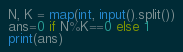Convert code to text. <code><loc_0><loc_0><loc_500><loc_500><_Python_>N, K = map(int, input().split())
ans=0 if N%K==0 else 1
print(ans)</code> 